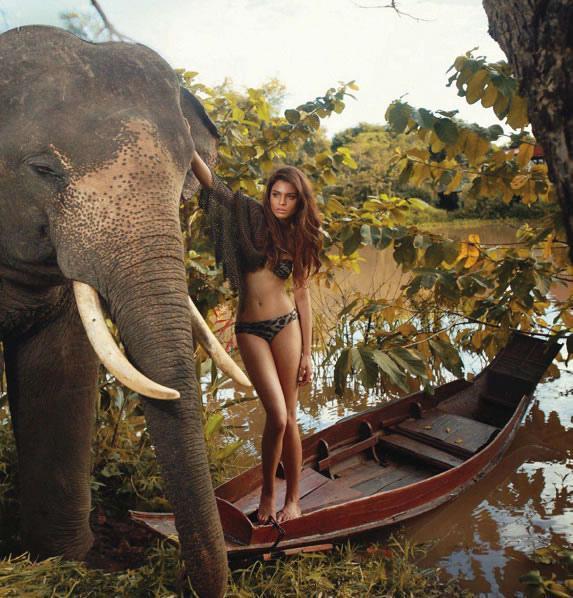How many elephants are in this scene?
Give a very brief answer. 1. 